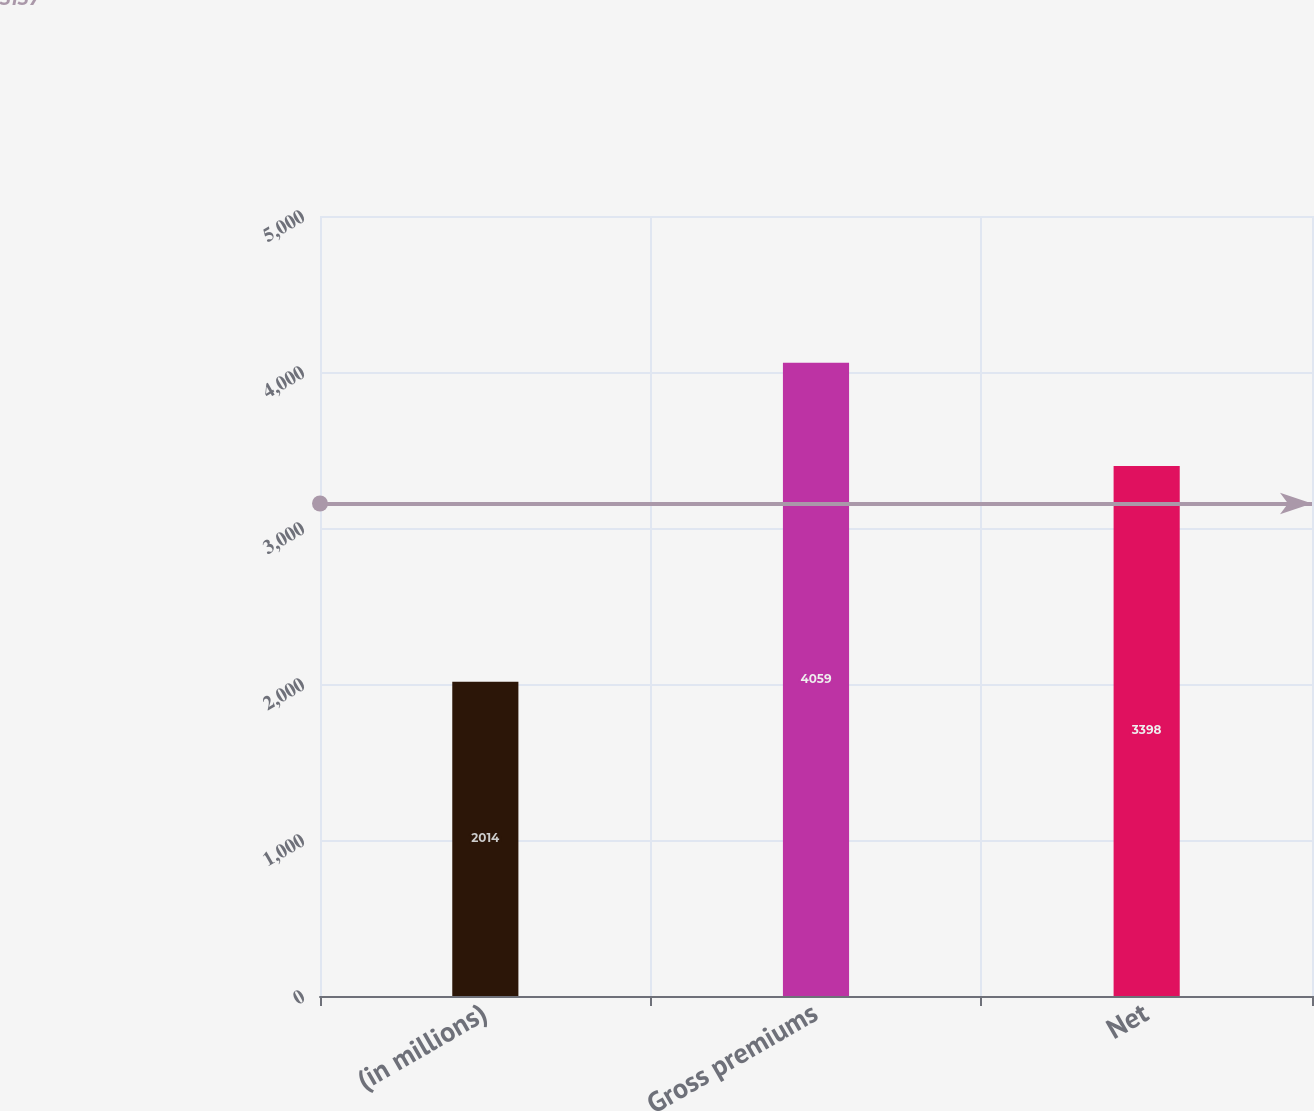Convert chart to OTSL. <chart><loc_0><loc_0><loc_500><loc_500><bar_chart><fcel>(in millions)<fcel>Gross premiums<fcel>Net<nl><fcel>2014<fcel>4059<fcel>3398<nl></chart> 